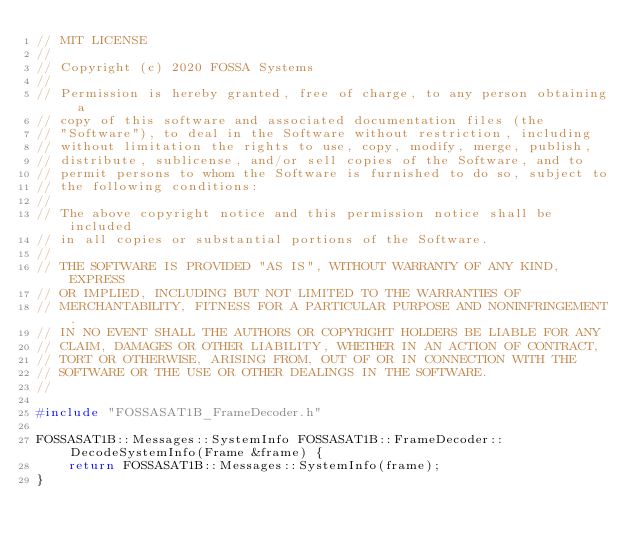Convert code to text. <code><loc_0><loc_0><loc_500><loc_500><_C++_>// MIT LICENSE
//
// Copyright (c) 2020 FOSSA Systems
//
// Permission is hereby granted, free of charge, to any person obtaining a
// copy of this software and associated documentation files (the
// "Software"), to deal in the Software without restriction, including
// without limitation the rights to use, copy, modify, merge, publish,
// distribute, sublicense, and/or sell copies of the Software, and to
// permit persons to whom the Software is furnished to do so, subject to
// the following conditions:
//
// The above copyright notice and this permission notice shall be included
// in all copies or substantial portions of the Software.
//
// THE SOFTWARE IS PROVIDED "AS IS", WITHOUT WARRANTY OF ANY KIND, EXPRESS
// OR IMPLIED, INCLUDING BUT NOT LIMITED TO THE WARRANTIES OF
// MERCHANTABILITY, FITNESS FOR A PARTICULAR PURPOSE AND NONINFRINGEMENT.
// IN NO EVENT SHALL THE AUTHORS OR COPYRIGHT HOLDERS BE LIABLE FOR ANY
// CLAIM, DAMAGES OR OTHER LIABILITY, WHETHER IN AN ACTION OF CONTRACT,
// TORT OR OTHERWISE, ARISING FROM, OUT OF OR IN CONNECTION WITH THE
// SOFTWARE OR THE USE OR OTHER DEALINGS IN THE SOFTWARE.
//

#include "FOSSASAT1B_FrameDecoder.h"

FOSSASAT1B::Messages::SystemInfo FOSSASAT1B::FrameDecoder::DecodeSystemInfo(Frame &frame) {
	return FOSSASAT1B::Messages::SystemInfo(frame);
}
</code> 